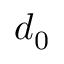Convert formula to latex. <formula><loc_0><loc_0><loc_500><loc_500>d _ { 0 }</formula> 